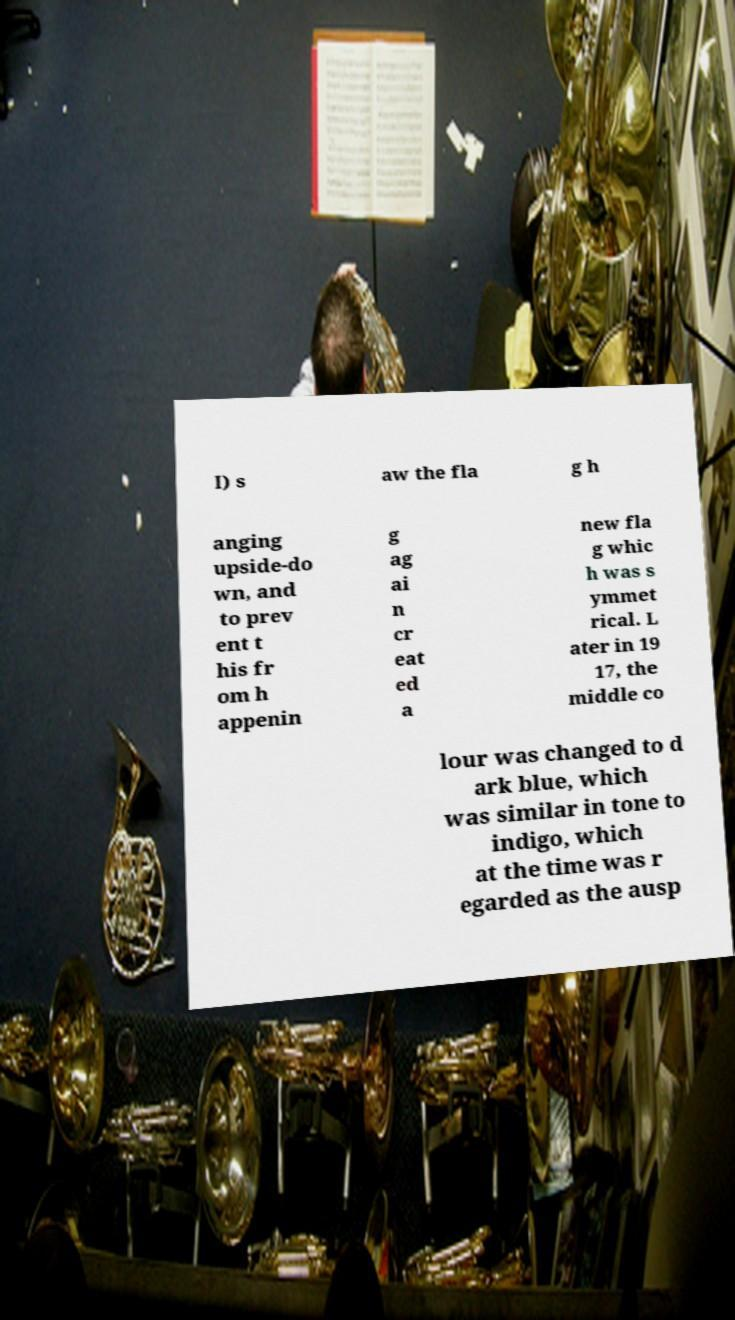Can you read and provide the text displayed in the image?This photo seems to have some interesting text. Can you extract and type it out for me? I) s aw the fla g h anging upside-do wn, and to prev ent t his fr om h appenin g ag ai n cr eat ed a new fla g whic h was s ymmet rical. L ater in 19 17, the middle co lour was changed to d ark blue, which was similar in tone to indigo, which at the time was r egarded as the ausp 